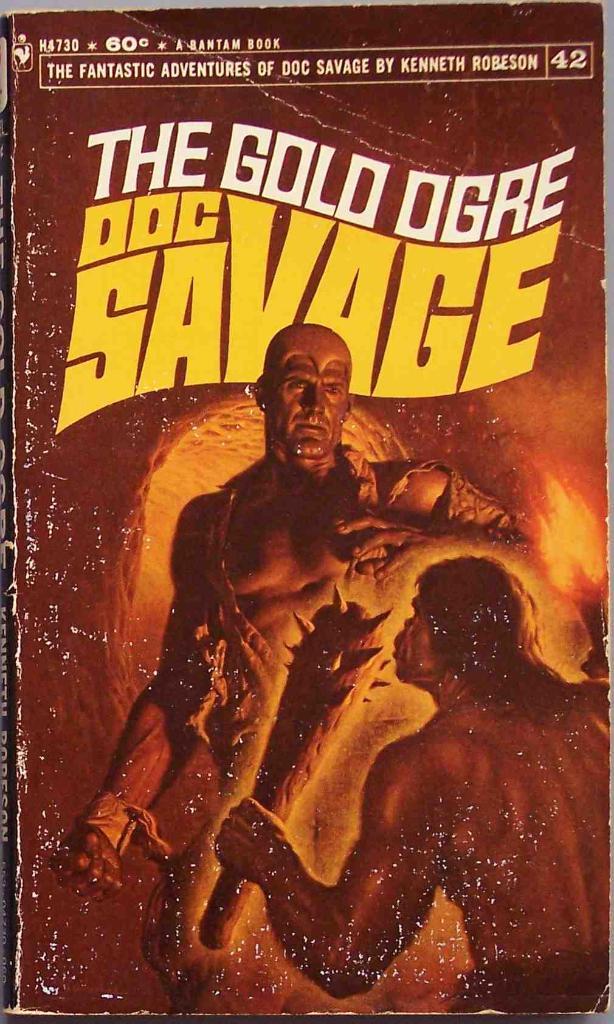Who is the author of the book?
Your answer should be compact. Kenneth robeson. What is the title of the book?
Ensure brevity in your answer.  The gold ogre. 